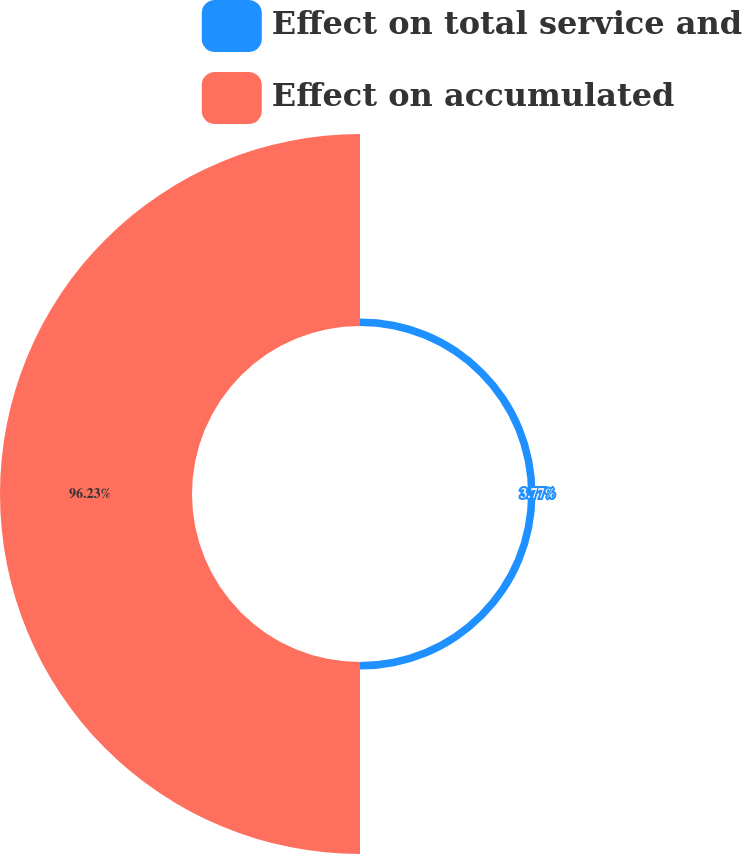Convert chart to OTSL. <chart><loc_0><loc_0><loc_500><loc_500><pie_chart><fcel>Effect on total service and<fcel>Effect on accumulated<nl><fcel>3.77%<fcel>96.23%<nl></chart> 